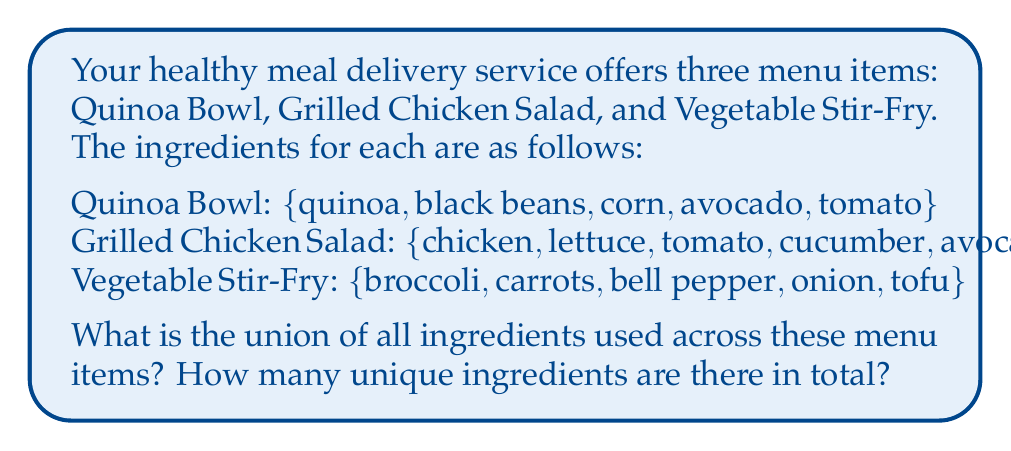Can you solve this math problem? To solve this problem, we need to find the union of the three sets of ingredients. The union of sets includes all unique elements from all sets combined.

Let's define our sets:
$A = \{quinoa, black beans, corn, avocado, tomato\}$
$B = \{chicken, lettuce, tomato, cucumber, avocado\}$
$C = \{broccoli, carrots, bell pepper, onion, tofu\}$

We want to find $A \cup B \cup C$

Step 1: Combine all ingredients from set A, B, and C.
$\{quinoa, black beans, corn, avocado, tomato, chicken, lettuce, cucumber, broccoli, carrots, bell pepper, onion, tofu\}$

Step 2: Remove duplicate ingredients (avocado and tomato appear twice).

Step 3: Count the number of unique ingredients.

The resulting set has 13 unique ingredients.
Answer: The union of all ingredients is:
$\{quinoa, black beans, corn, avocado, tomato, chicken, lettuce, cucumber, broccoli, carrots, bell pepper, onion, tofu\}$

There are 13 unique ingredients in total. 